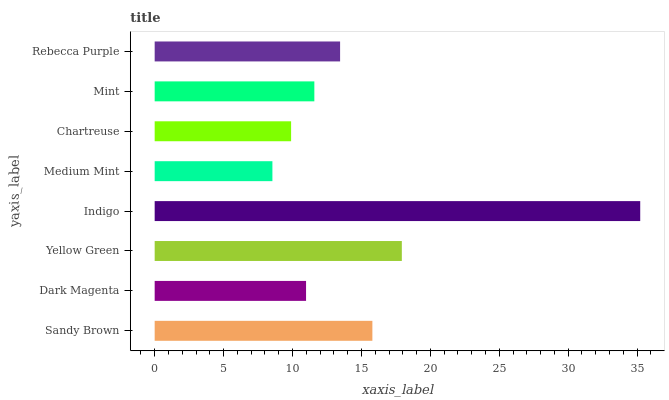Is Medium Mint the minimum?
Answer yes or no. Yes. Is Indigo the maximum?
Answer yes or no. Yes. Is Dark Magenta the minimum?
Answer yes or no. No. Is Dark Magenta the maximum?
Answer yes or no. No. Is Sandy Brown greater than Dark Magenta?
Answer yes or no. Yes. Is Dark Magenta less than Sandy Brown?
Answer yes or no. Yes. Is Dark Magenta greater than Sandy Brown?
Answer yes or no. No. Is Sandy Brown less than Dark Magenta?
Answer yes or no. No. Is Rebecca Purple the high median?
Answer yes or no. Yes. Is Mint the low median?
Answer yes or no. Yes. Is Medium Mint the high median?
Answer yes or no. No. Is Indigo the low median?
Answer yes or no. No. 